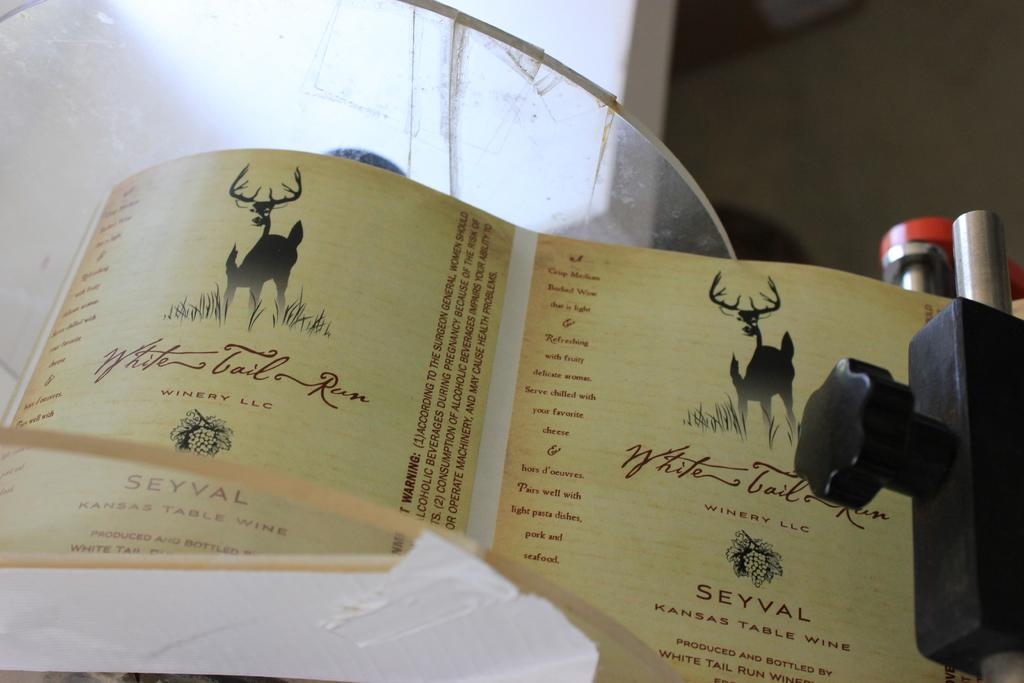<image>
Relay a brief, clear account of the picture shown. An label which reads Kansas Table Wine and has a deer picture. 